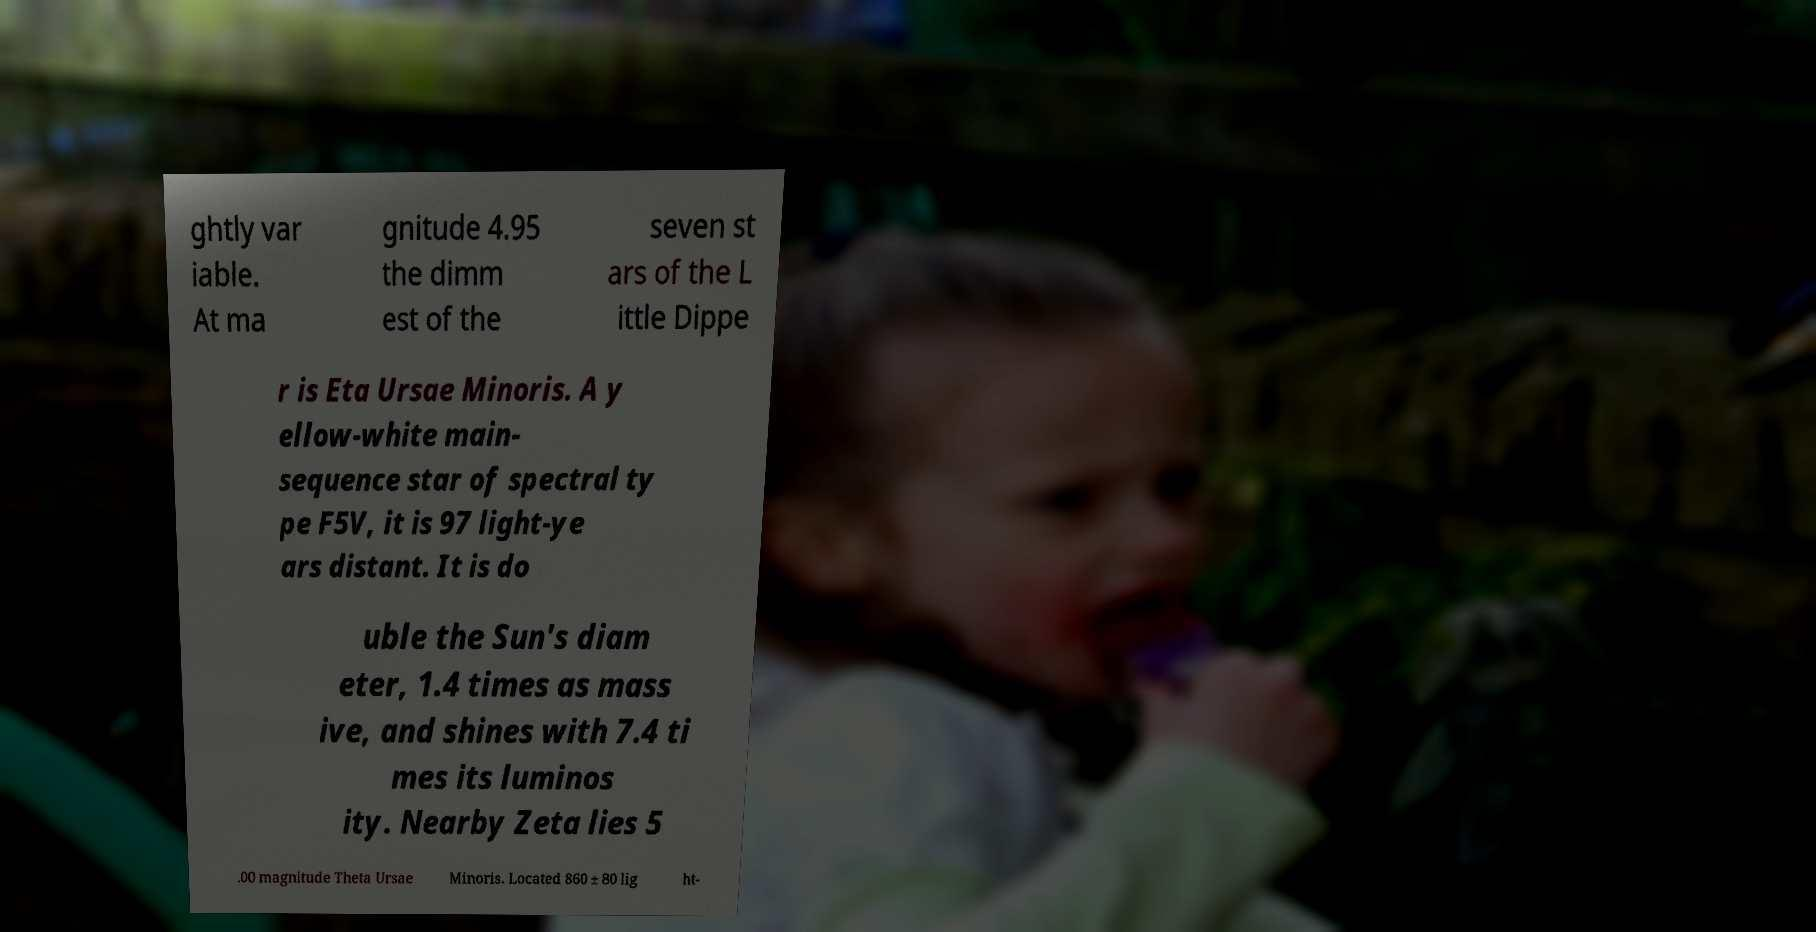Can you read and provide the text displayed in the image?This photo seems to have some interesting text. Can you extract and type it out for me? ghtly var iable. At ma gnitude 4.95 the dimm est of the seven st ars of the L ittle Dippe r is Eta Ursae Minoris. A y ellow-white main- sequence star of spectral ty pe F5V, it is 97 light-ye ars distant. It is do uble the Sun's diam eter, 1.4 times as mass ive, and shines with 7.4 ti mes its luminos ity. Nearby Zeta lies 5 .00 magnitude Theta Ursae Minoris. Located 860 ± 80 lig ht- 